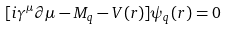<formula> <loc_0><loc_0><loc_500><loc_500>[ i \gamma ^ { \mu } \partial \mu - M _ { q } - V ( r ) ] \psi _ { q } ( r ) = 0</formula> 